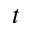Convert formula to latex. <formula><loc_0><loc_0><loc_500><loc_500>t</formula> 